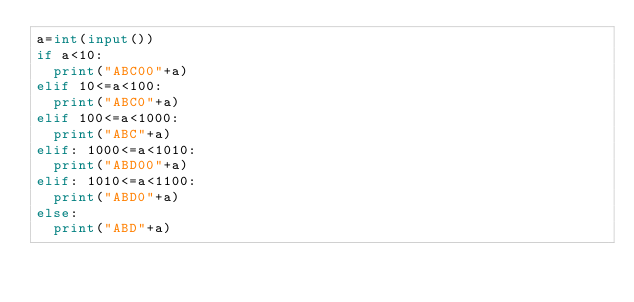<code> <loc_0><loc_0><loc_500><loc_500><_Python_>a=int(input())
if a<10:
  print("ABC00"+a)
elif 10<=a<100:
  print("ABC0"+a)
elif 100<=a<1000:
  print("ABC"+a)
elif: 1000<=a<1010:
  print("ABD00"+a)
elif: 1010<=a<1100:
  print("ABD0"+a)
else:
  print("ABD"+a)</code> 